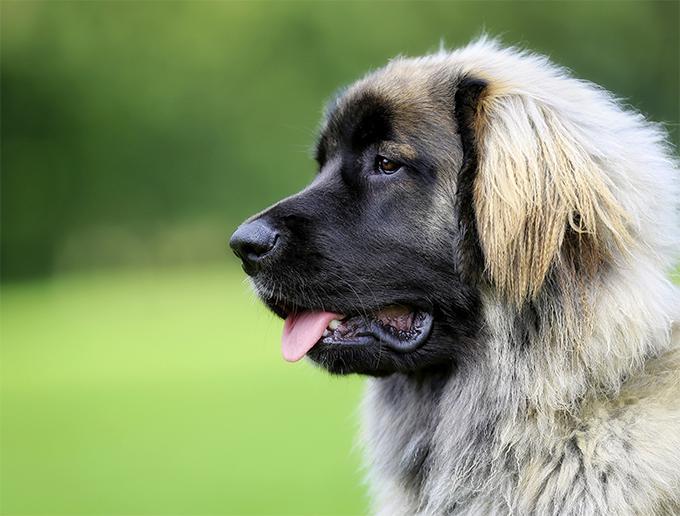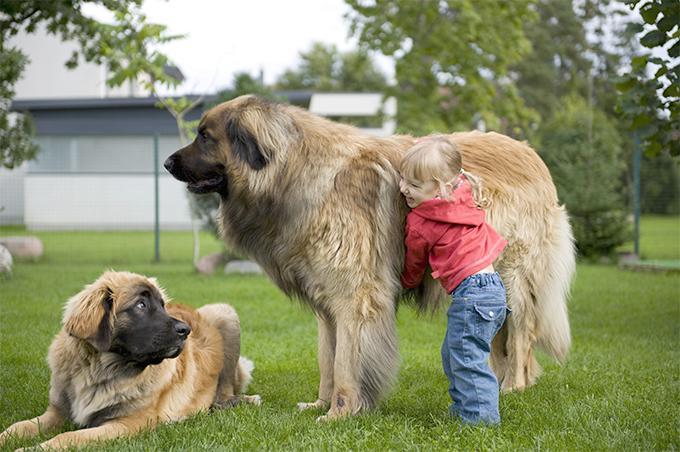The first image is the image on the left, the second image is the image on the right. For the images displayed, is the sentence "One dog is positioned on the back of another dog." factually correct? Answer yes or no. No. The first image is the image on the left, the second image is the image on the right. For the images displayed, is the sentence "There are two dogs in the image on the right." factually correct? Answer yes or no. Yes. 